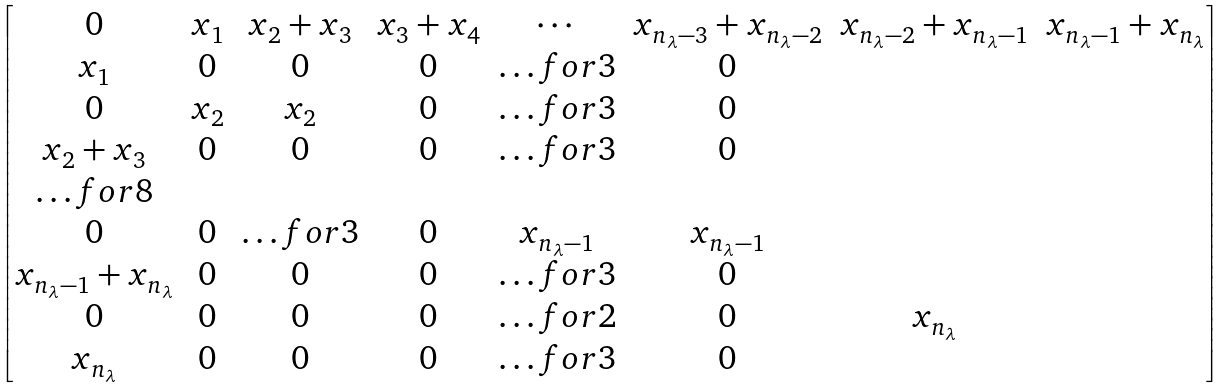<formula> <loc_0><loc_0><loc_500><loc_500>\begin{bmatrix} 0 & x _ { 1 } & x _ { 2 } + x _ { 3 } & x _ { 3 } + x _ { 4 } & \cdots & x _ { n _ { \lambda } - 3 } + x _ { n _ { \lambda } - 2 } & x _ { n _ { \lambda } - 2 } + x _ { n _ { \lambda } - 1 } & x _ { n _ { \lambda } - 1 } + x _ { n _ { \lambda } } \\ x _ { 1 } & 0 & 0 & 0 & \hdots f o r { 3 } & 0 \\ 0 & x _ { 2 } & x _ { 2 } & 0 & \hdots f o r { 3 } & 0 \\ x _ { 2 } + x _ { 3 } & 0 & 0 & 0 & \hdots f o r { 3 } & 0 \\ \hdots f o r { 8 } \\ 0 & 0 & \hdots f o r { 3 } & 0 & x _ { n _ { \lambda } - 1 } & x _ { n _ { \lambda } - 1 } \\ x _ { n _ { \lambda } - 1 } + x _ { n _ { \lambda } } & 0 & 0 & 0 & \hdots f o r { 3 } & 0 \\ 0 & 0 & 0 & 0 & \hdots f o r { 2 } & 0 & x _ { n _ { \lambda } } \\ x _ { n _ { \lambda } } & 0 & 0 & 0 & \hdots f o r { 3 } & 0 \\ \end{bmatrix}</formula> 